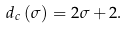Convert formula to latex. <formula><loc_0><loc_0><loc_500><loc_500>d _ { c } \left ( \sigma \right ) = 2 \sigma + 2 .</formula> 